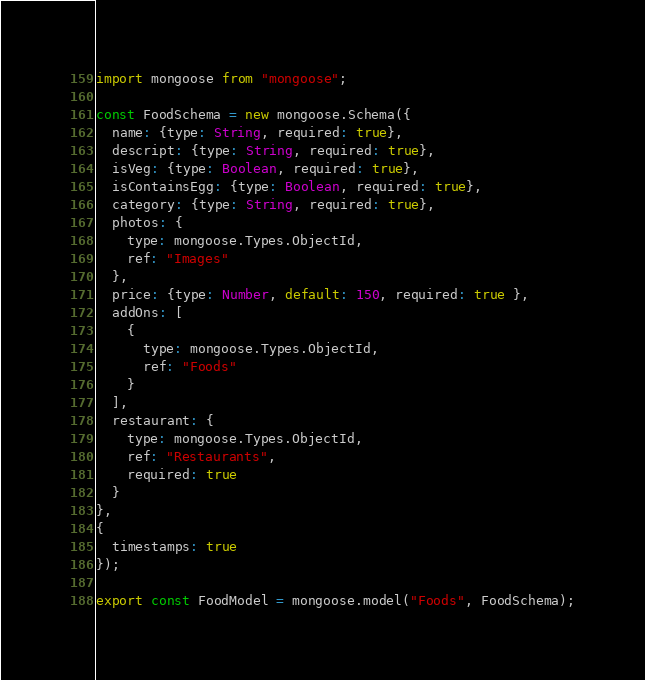<code> <loc_0><loc_0><loc_500><loc_500><_JavaScript_>import mongoose from "mongoose";

const FoodSchema = new mongoose.Schema({
  name: {type: String, required: true},
  descript: {type: String, required: true},
  isVeg: {type: Boolean, required: true},
  isContainsEgg: {type: Boolean, required: true},
  category: {type: String, required: true},
  photos: {
    type: mongoose.Types.ObjectId,
    ref: "Images"
  },
  price: {type: Number, default: 150, required: true },
  addOns: [
    {
      type: mongoose.Types.ObjectId,
      ref: "Foods"
    }
  ],
  restaurant: {
    type: mongoose.Types.ObjectId,
    ref: "Restaurants",
    required: true
  }
},
{
  timestamps: true
});

export const FoodModel = mongoose.model("Foods", FoodSchema);
</code> 